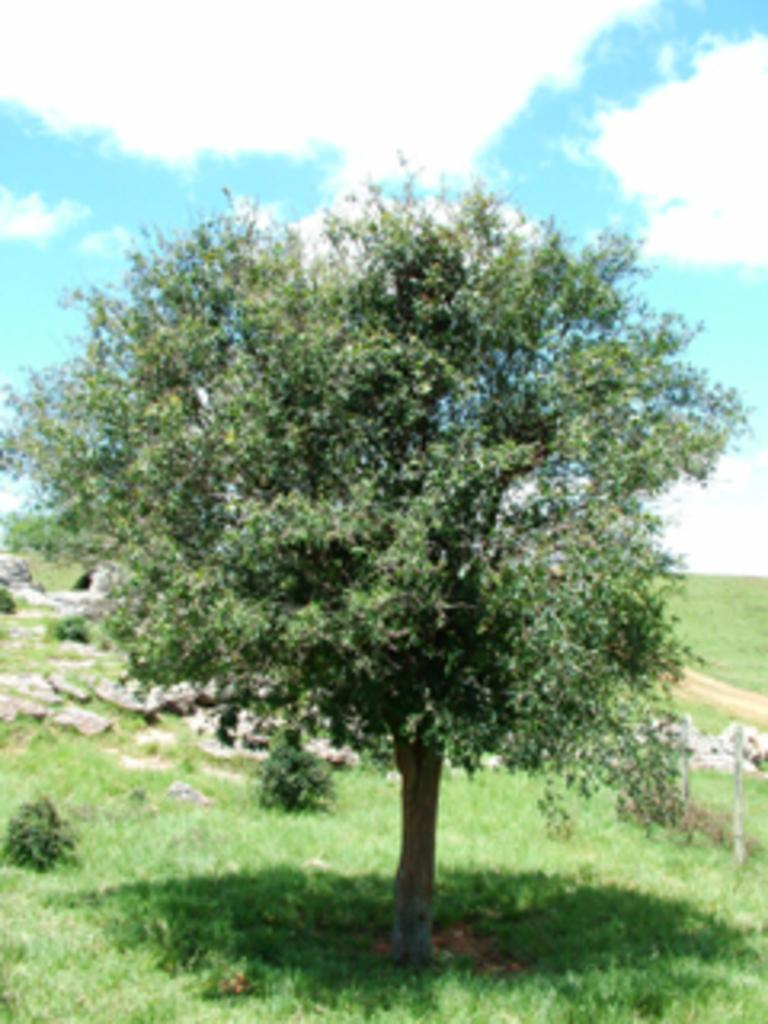What type of vegetation is present in the image? There is a tree and grass in the image. What other elements can be seen on the ground in the image? There are stones in the image. Is there any indication of a path or walkway in the image? Yes, there is a path in the image. How would you describe the sky in the image? The sky is cloudy and pale blue in the image. How many passengers are visible in the image? There are no passengers present in the image. Is there a group of people gathered around the tree in the image? There is no group of people present in the image. 